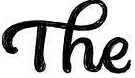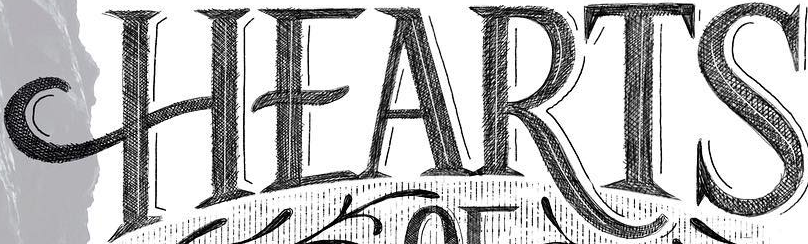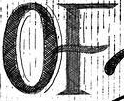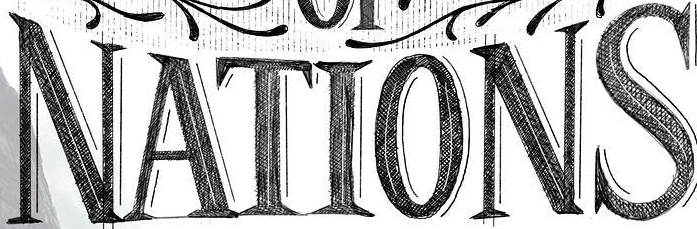What text appears in these images from left to right, separated by a semicolon? The; HEARTS; OF; NATIONS 